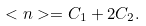<formula> <loc_0><loc_0><loc_500><loc_500>< n > = C _ { 1 } + 2 C _ { 2 } .</formula> 